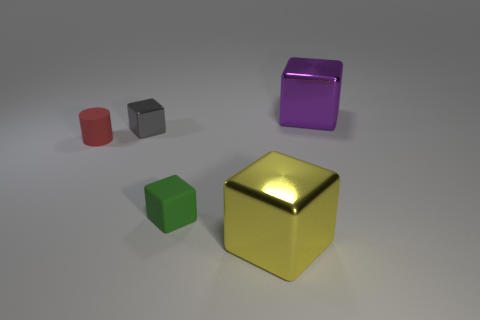Add 1 yellow shiny cubes. How many objects exist? 6 Subtract all cylinders. How many objects are left? 4 Add 5 green blocks. How many green blocks are left? 6 Add 4 small red matte objects. How many small red matte objects exist? 5 Subtract 0 gray cylinders. How many objects are left? 5 Subtract all yellow things. Subtract all gray metal blocks. How many objects are left? 3 